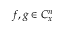Convert formula to latex. <formula><loc_0><loc_0><loc_500><loc_500>f , g \in C _ { x } ^ { n }</formula> 